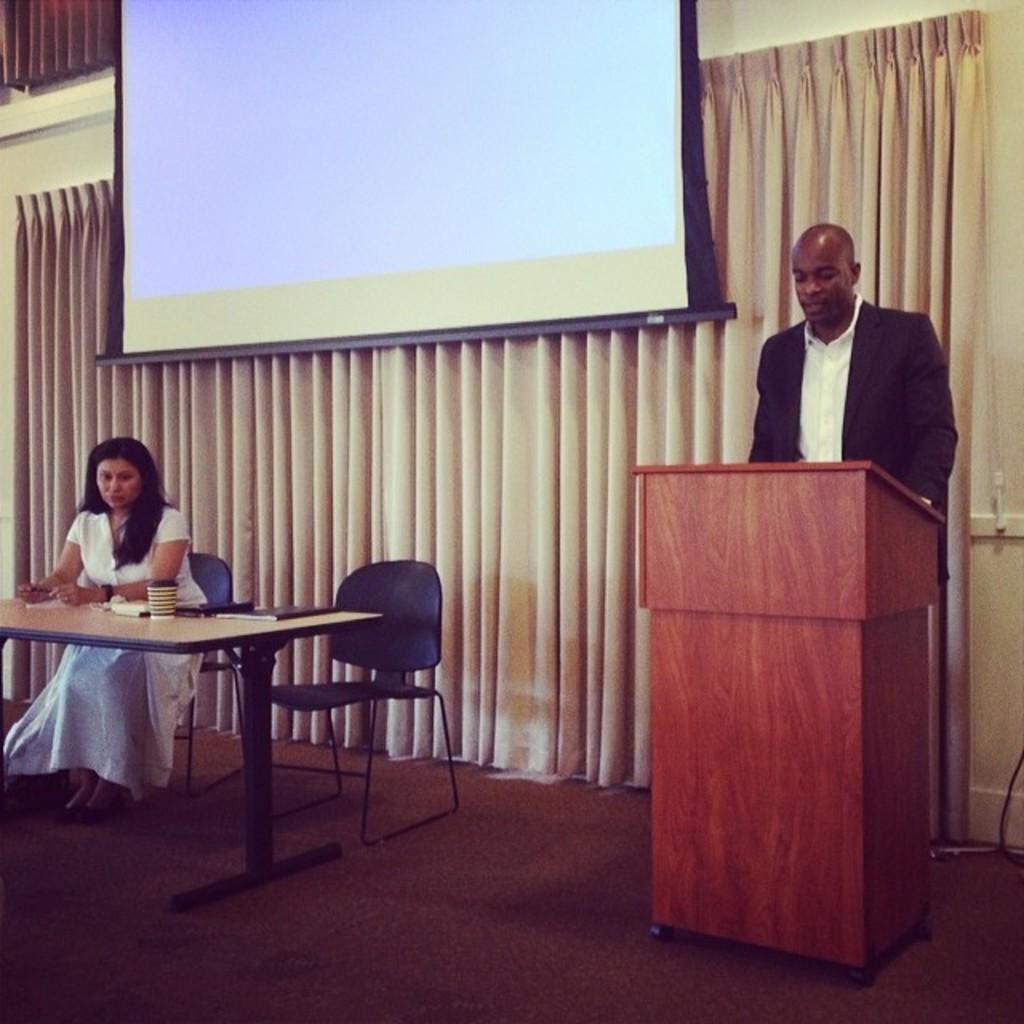Describe this image in one or two sentences. Here on the right side we can see a person near a speech desk standing and on the left side we can see a woman sitting on a chair with a table in front of her having a cup place on stand behind them we can see a curtain and a projector screen 